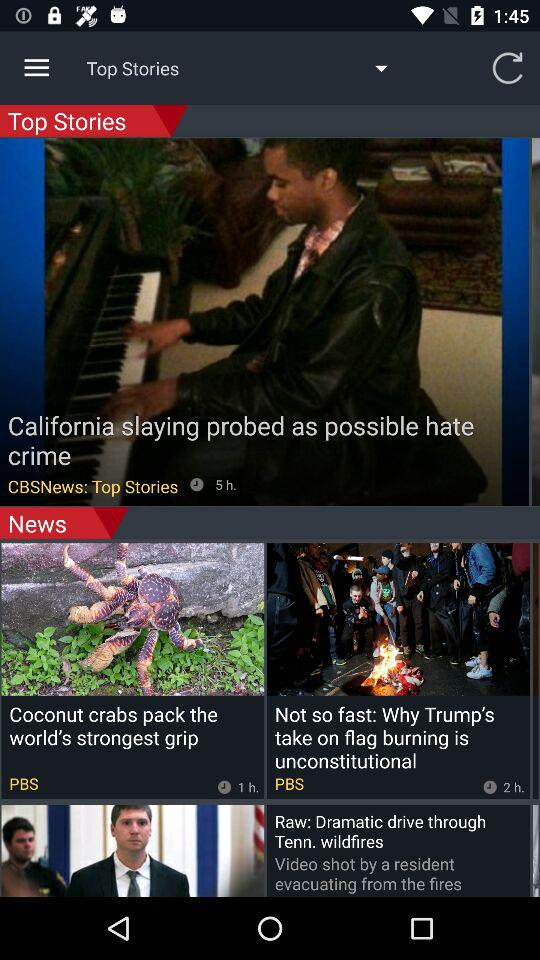When was the news in the top stories uploaded? The news was "California slaying probed as possible hate crime". 